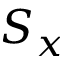Convert formula to latex. <formula><loc_0><loc_0><loc_500><loc_500>S _ { x }</formula> 